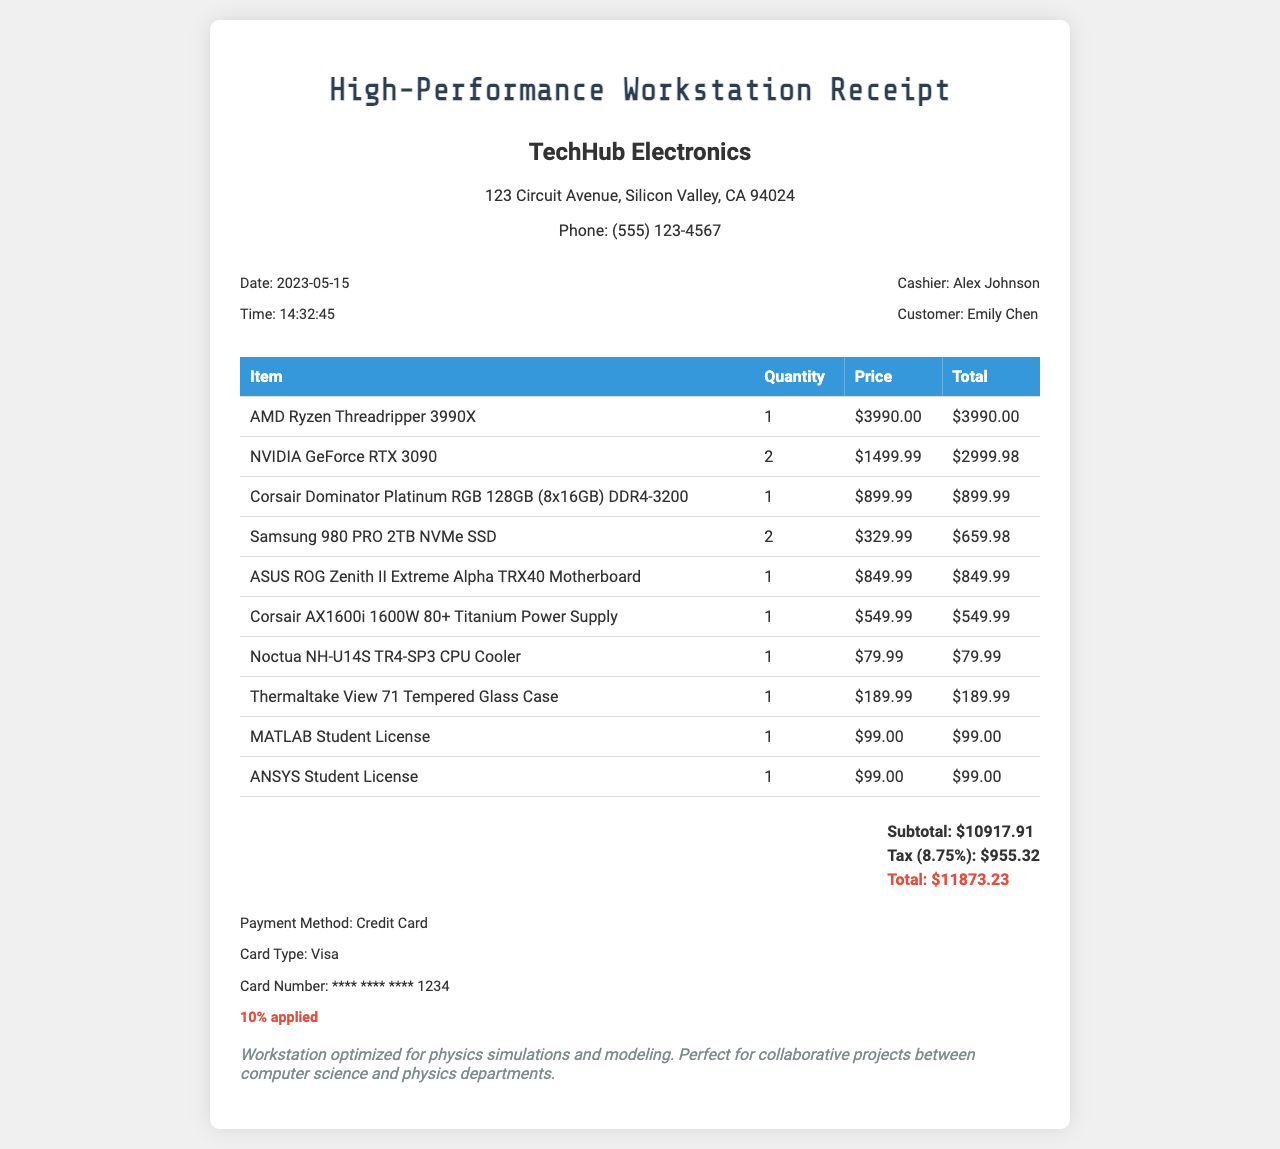What is the store name? The store name is presented at the top of the receipt.
Answer: TechHub Electronics What is the total amount paid? The total amount is calculated at the bottom of the receipt, including subtotal and tax.
Answer: 11873.23 Who was the cashier? The cashier's name is listed in the receipt details section.
Answer: Alex Johnson What is the student discount rate? The student discount is mentioned in the payment information section of the receipt.
Answer: 10% applied How many NVIDIA GeForce RTX 3090 were purchased? The quantity of the item is specified in the list of items purchased.
Answer: 2 What is the subtotal amount? The subtotal is listed before tax calculations at the bottom of the receipt.
Answer: 10917.91 When was the receipt issued? The date of the purchase is noted in the receipt details section.
Answer: 2023-05-15 What kind of case was purchased? The name of the case is included in the items list on the receipt.
Answer: Thermaltake View 71 Tempered Glass Case What payment method was used? The payment method is stated in the payment information section of the receipt.
Answer: Credit Card 